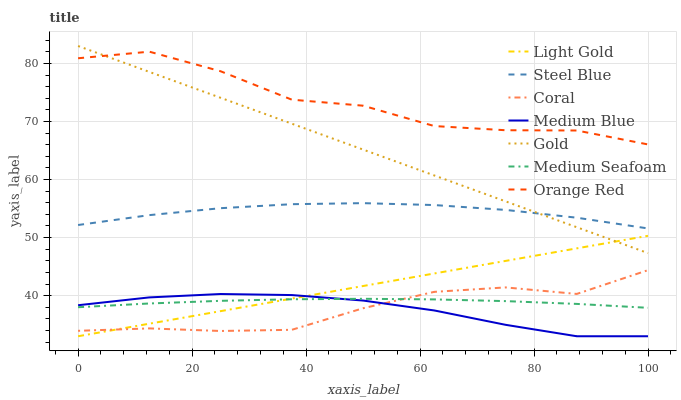Does Medium Blue have the minimum area under the curve?
Answer yes or no. Yes. Does Orange Red have the maximum area under the curve?
Answer yes or no. Yes. Does Coral have the minimum area under the curve?
Answer yes or no. No. Does Coral have the maximum area under the curve?
Answer yes or no. No. Is Light Gold the smoothest?
Answer yes or no. Yes. Is Orange Red the roughest?
Answer yes or no. Yes. Is Coral the smoothest?
Answer yes or no. No. Is Coral the roughest?
Answer yes or no. No. Does Coral have the lowest value?
Answer yes or no. No. Does Gold have the highest value?
Answer yes or no. Yes. Does Coral have the highest value?
Answer yes or no. No. Is Medium Blue less than Gold?
Answer yes or no. Yes. Is Gold greater than Coral?
Answer yes or no. Yes. Does Gold intersect Orange Red?
Answer yes or no. Yes. Is Gold less than Orange Red?
Answer yes or no. No. Is Gold greater than Orange Red?
Answer yes or no. No. Does Medium Blue intersect Gold?
Answer yes or no. No. 